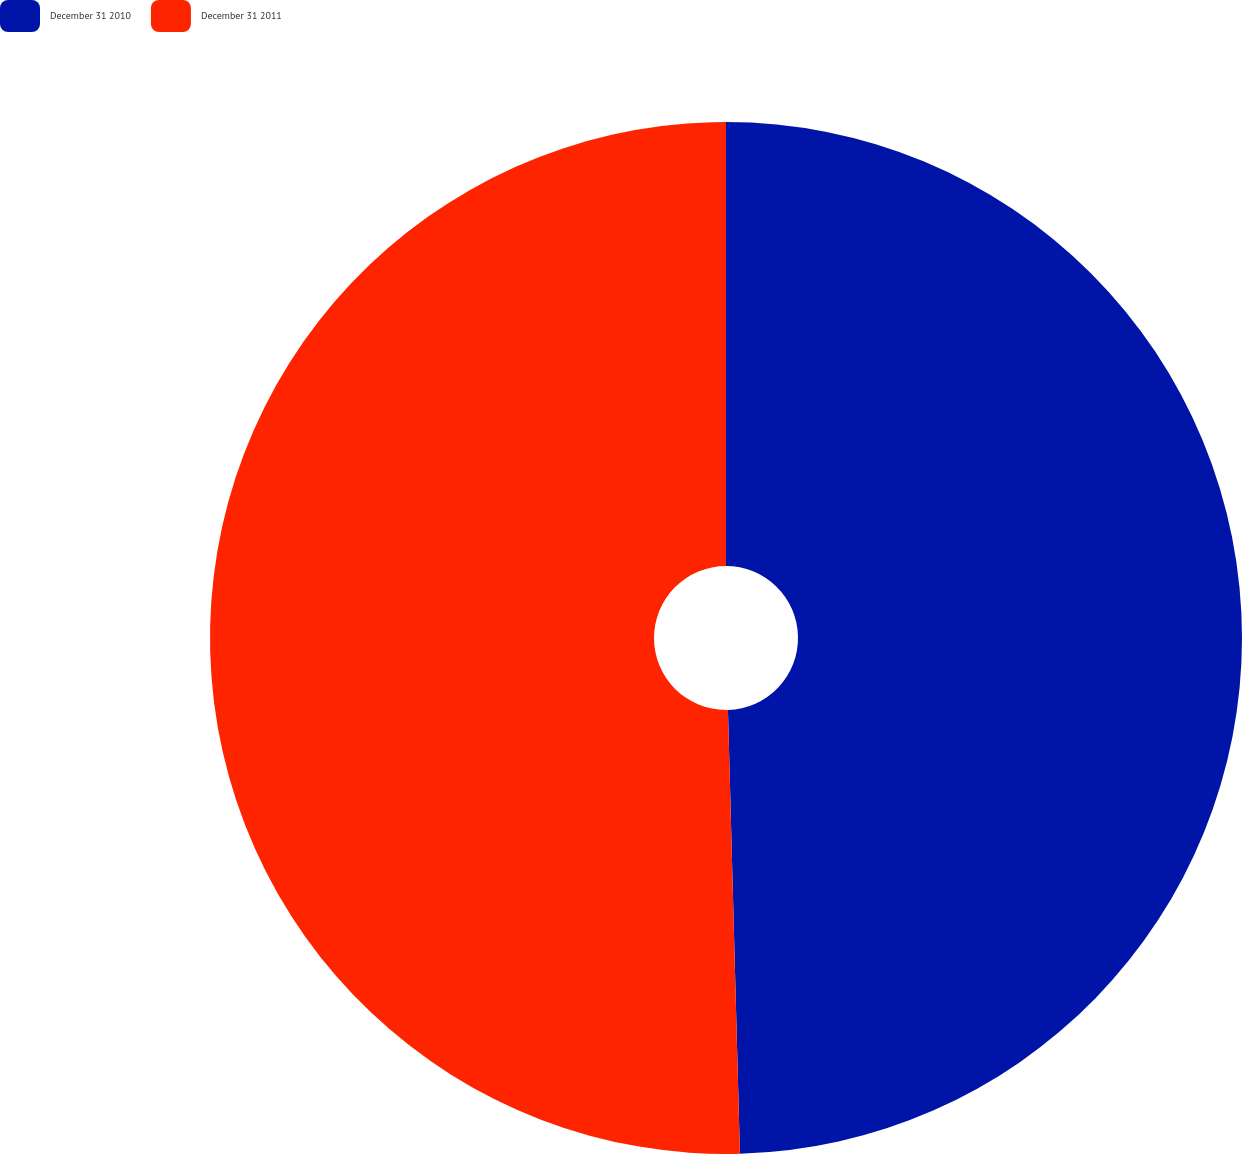<chart> <loc_0><loc_0><loc_500><loc_500><pie_chart><fcel>December 31 2010<fcel>December 31 2011<nl><fcel>49.57%<fcel>50.43%<nl></chart> 